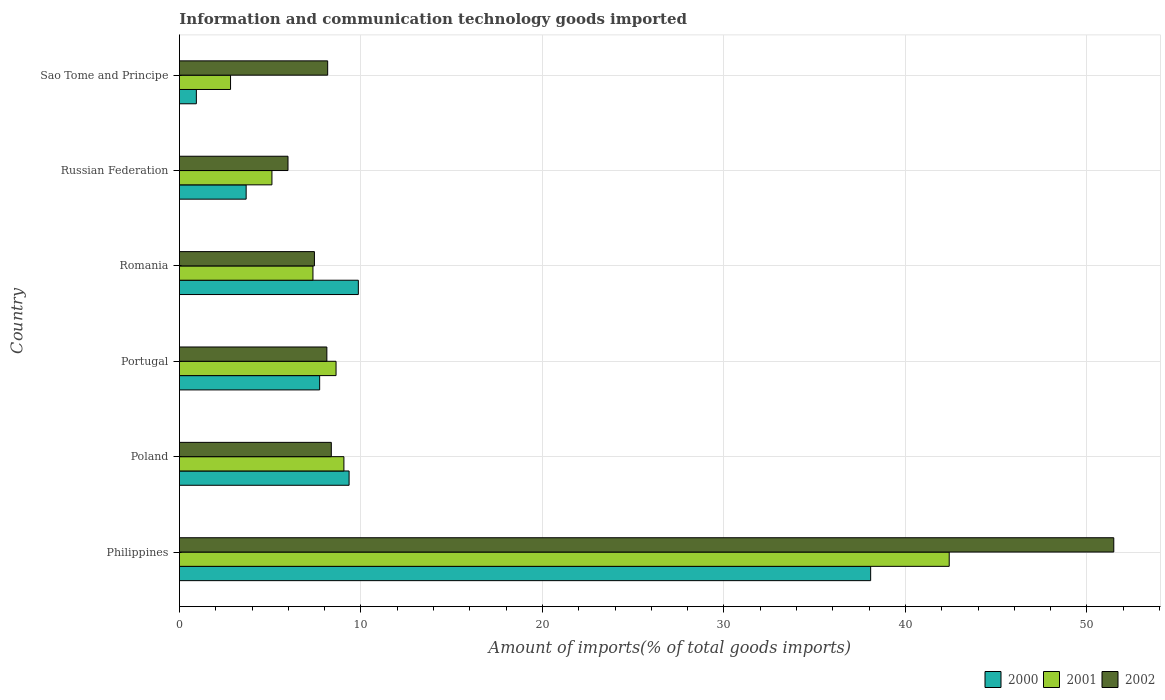How many groups of bars are there?
Your answer should be very brief. 6. Are the number of bars per tick equal to the number of legend labels?
Make the answer very short. Yes. What is the label of the 1st group of bars from the top?
Your answer should be compact. Sao Tome and Principe. In how many cases, is the number of bars for a given country not equal to the number of legend labels?
Ensure brevity in your answer.  0. What is the amount of goods imported in 2002 in Russian Federation?
Your answer should be very brief. 5.98. Across all countries, what is the maximum amount of goods imported in 2000?
Your response must be concise. 38.08. Across all countries, what is the minimum amount of goods imported in 2000?
Keep it short and to the point. 0.93. In which country was the amount of goods imported in 2001 minimum?
Keep it short and to the point. Sao Tome and Principe. What is the total amount of goods imported in 2000 in the graph?
Your answer should be very brief. 69.63. What is the difference between the amount of goods imported in 2000 in Portugal and that in Romania?
Keep it short and to the point. -2.13. What is the difference between the amount of goods imported in 2001 in Poland and the amount of goods imported in 2000 in Russian Federation?
Provide a short and direct response. 5.38. What is the average amount of goods imported in 2001 per country?
Make the answer very short. 12.56. What is the difference between the amount of goods imported in 2002 and amount of goods imported in 2000 in Poland?
Your answer should be very brief. -0.98. What is the ratio of the amount of goods imported in 2000 in Portugal to that in Sao Tome and Principe?
Offer a very short reply. 8.28. Is the amount of goods imported in 2000 in Philippines less than that in Portugal?
Offer a terse response. No. Is the difference between the amount of goods imported in 2002 in Philippines and Poland greater than the difference between the amount of goods imported in 2000 in Philippines and Poland?
Provide a short and direct response. Yes. What is the difference between the highest and the second highest amount of goods imported in 2000?
Your answer should be very brief. 28.22. What is the difference between the highest and the lowest amount of goods imported in 2000?
Provide a succinct answer. 37.15. Is the sum of the amount of goods imported in 2001 in Portugal and Sao Tome and Principe greater than the maximum amount of goods imported in 2000 across all countries?
Offer a terse response. No. What does the 3rd bar from the bottom in Russian Federation represents?
Offer a terse response. 2002. Is it the case that in every country, the sum of the amount of goods imported in 2000 and amount of goods imported in 2001 is greater than the amount of goods imported in 2002?
Your answer should be very brief. No. How many bars are there?
Offer a very short reply. 18. Are all the bars in the graph horizontal?
Give a very brief answer. Yes. How many countries are there in the graph?
Your answer should be compact. 6. Does the graph contain any zero values?
Your response must be concise. No. Does the graph contain grids?
Your answer should be very brief. Yes. Where does the legend appear in the graph?
Your answer should be very brief. Bottom right. What is the title of the graph?
Keep it short and to the point. Information and communication technology goods imported. Does "1979" appear as one of the legend labels in the graph?
Ensure brevity in your answer.  No. What is the label or title of the X-axis?
Provide a succinct answer. Amount of imports(% of total goods imports). What is the label or title of the Y-axis?
Provide a succinct answer. Country. What is the Amount of imports(% of total goods imports) of 2000 in Philippines?
Your response must be concise. 38.08. What is the Amount of imports(% of total goods imports) of 2001 in Philippines?
Offer a very short reply. 42.41. What is the Amount of imports(% of total goods imports) of 2002 in Philippines?
Offer a terse response. 51.48. What is the Amount of imports(% of total goods imports) of 2000 in Poland?
Make the answer very short. 9.35. What is the Amount of imports(% of total goods imports) in 2001 in Poland?
Your answer should be compact. 9.06. What is the Amount of imports(% of total goods imports) in 2002 in Poland?
Offer a terse response. 8.37. What is the Amount of imports(% of total goods imports) in 2000 in Portugal?
Offer a very short reply. 7.73. What is the Amount of imports(% of total goods imports) of 2001 in Portugal?
Your response must be concise. 8.63. What is the Amount of imports(% of total goods imports) in 2002 in Portugal?
Offer a terse response. 8.12. What is the Amount of imports(% of total goods imports) of 2000 in Romania?
Ensure brevity in your answer.  9.86. What is the Amount of imports(% of total goods imports) of 2001 in Romania?
Your answer should be compact. 7.36. What is the Amount of imports(% of total goods imports) in 2002 in Romania?
Provide a succinct answer. 7.44. What is the Amount of imports(% of total goods imports) of 2000 in Russian Federation?
Provide a succinct answer. 3.68. What is the Amount of imports(% of total goods imports) of 2001 in Russian Federation?
Give a very brief answer. 5.1. What is the Amount of imports(% of total goods imports) in 2002 in Russian Federation?
Ensure brevity in your answer.  5.98. What is the Amount of imports(% of total goods imports) in 2000 in Sao Tome and Principe?
Keep it short and to the point. 0.93. What is the Amount of imports(% of total goods imports) in 2001 in Sao Tome and Principe?
Offer a terse response. 2.82. What is the Amount of imports(% of total goods imports) in 2002 in Sao Tome and Principe?
Ensure brevity in your answer.  8.17. Across all countries, what is the maximum Amount of imports(% of total goods imports) in 2000?
Your response must be concise. 38.08. Across all countries, what is the maximum Amount of imports(% of total goods imports) of 2001?
Your answer should be very brief. 42.41. Across all countries, what is the maximum Amount of imports(% of total goods imports) of 2002?
Offer a very short reply. 51.48. Across all countries, what is the minimum Amount of imports(% of total goods imports) of 2000?
Offer a terse response. 0.93. Across all countries, what is the minimum Amount of imports(% of total goods imports) of 2001?
Make the answer very short. 2.82. Across all countries, what is the minimum Amount of imports(% of total goods imports) in 2002?
Provide a short and direct response. 5.98. What is the total Amount of imports(% of total goods imports) in 2000 in the graph?
Provide a short and direct response. 69.63. What is the total Amount of imports(% of total goods imports) in 2001 in the graph?
Provide a short and direct response. 75.37. What is the total Amount of imports(% of total goods imports) in 2002 in the graph?
Keep it short and to the point. 89.56. What is the difference between the Amount of imports(% of total goods imports) of 2000 in Philippines and that in Poland?
Offer a terse response. 28.73. What is the difference between the Amount of imports(% of total goods imports) of 2001 in Philippines and that in Poland?
Your response must be concise. 33.35. What is the difference between the Amount of imports(% of total goods imports) in 2002 in Philippines and that in Poland?
Make the answer very short. 43.11. What is the difference between the Amount of imports(% of total goods imports) of 2000 in Philippines and that in Portugal?
Your answer should be compact. 30.36. What is the difference between the Amount of imports(% of total goods imports) of 2001 in Philippines and that in Portugal?
Provide a succinct answer. 33.78. What is the difference between the Amount of imports(% of total goods imports) in 2002 in Philippines and that in Portugal?
Your answer should be compact. 43.35. What is the difference between the Amount of imports(% of total goods imports) in 2000 in Philippines and that in Romania?
Ensure brevity in your answer.  28.22. What is the difference between the Amount of imports(% of total goods imports) in 2001 in Philippines and that in Romania?
Give a very brief answer. 35.05. What is the difference between the Amount of imports(% of total goods imports) in 2002 in Philippines and that in Romania?
Your answer should be compact. 44.04. What is the difference between the Amount of imports(% of total goods imports) of 2000 in Philippines and that in Russian Federation?
Ensure brevity in your answer.  34.41. What is the difference between the Amount of imports(% of total goods imports) in 2001 in Philippines and that in Russian Federation?
Keep it short and to the point. 37.31. What is the difference between the Amount of imports(% of total goods imports) in 2002 in Philippines and that in Russian Federation?
Provide a short and direct response. 45.49. What is the difference between the Amount of imports(% of total goods imports) in 2000 in Philippines and that in Sao Tome and Principe?
Provide a short and direct response. 37.15. What is the difference between the Amount of imports(% of total goods imports) in 2001 in Philippines and that in Sao Tome and Principe?
Your response must be concise. 39.59. What is the difference between the Amount of imports(% of total goods imports) in 2002 in Philippines and that in Sao Tome and Principe?
Provide a succinct answer. 43.31. What is the difference between the Amount of imports(% of total goods imports) of 2000 in Poland and that in Portugal?
Your response must be concise. 1.62. What is the difference between the Amount of imports(% of total goods imports) of 2001 in Poland and that in Portugal?
Provide a short and direct response. 0.43. What is the difference between the Amount of imports(% of total goods imports) of 2002 in Poland and that in Portugal?
Your response must be concise. 0.25. What is the difference between the Amount of imports(% of total goods imports) in 2000 in Poland and that in Romania?
Your response must be concise. -0.51. What is the difference between the Amount of imports(% of total goods imports) of 2001 in Poland and that in Romania?
Provide a succinct answer. 1.71. What is the difference between the Amount of imports(% of total goods imports) of 2002 in Poland and that in Romania?
Your response must be concise. 0.93. What is the difference between the Amount of imports(% of total goods imports) of 2000 in Poland and that in Russian Federation?
Your response must be concise. 5.67. What is the difference between the Amount of imports(% of total goods imports) in 2001 in Poland and that in Russian Federation?
Your answer should be compact. 3.97. What is the difference between the Amount of imports(% of total goods imports) of 2002 in Poland and that in Russian Federation?
Give a very brief answer. 2.39. What is the difference between the Amount of imports(% of total goods imports) of 2000 in Poland and that in Sao Tome and Principe?
Make the answer very short. 8.41. What is the difference between the Amount of imports(% of total goods imports) of 2001 in Poland and that in Sao Tome and Principe?
Make the answer very short. 6.25. What is the difference between the Amount of imports(% of total goods imports) in 2002 in Poland and that in Sao Tome and Principe?
Give a very brief answer. 0.2. What is the difference between the Amount of imports(% of total goods imports) of 2000 in Portugal and that in Romania?
Keep it short and to the point. -2.13. What is the difference between the Amount of imports(% of total goods imports) in 2001 in Portugal and that in Romania?
Provide a short and direct response. 1.27. What is the difference between the Amount of imports(% of total goods imports) in 2002 in Portugal and that in Romania?
Offer a very short reply. 0.69. What is the difference between the Amount of imports(% of total goods imports) of 2000 in Portugal and that in Russian Federation?
Offer a terse response. 4.05. What is the difference between the Amount of imports(% of total goods imports) in 2001 in Portugal and that in Russian Federation?
Your response must be concise. 3.53. What is the difference between the Amount of imports(% of total goods imports) of 2002 in Portugal and that in Russian Federation?
Offer a terse response. 2.14. What is the difference between the Amount of imports(% of total goods imports) of 2000 in Portugal and that in Sao Tome and Principe?
Make the answer very short. 6.79. What is the difference between the Amount of imports(% of total goods imports) of 2001 in Portugal and that in Sao Tome and Principe?
Ensure brevity in your answer.  5.81. What is the difference between the Amount of imports(% of total goods imports) in 2002 in Portugal and that in Sao Tome and Principe?
Your answer should be very brief. -0.04. What is the difference between the Amount of imports(% of total goods imports) of 2000 in Romania and that in Russian Federation?
Offer a very short reply. 6.18. What is the difference between the Amount of imports(% of total goods imports) in 2001 in Romania and that in Russian Federation?
Ensure brevity in your answer.  2.26. What is the difference between the Amount of imports(% of total goods imports) of 2002 in Romania and that in Russian Federation?
Provide a short and direct response. 1.46. What is the difference between the Amount of imports(% of total goods imports) in 2000 in Romania and that in Sao Tome and Principe?
Your response must be concise. 8.92. What is the difference between the Amount of imports(% of total goods imports) of 2001 in Romania and that in Sao Tome and Principe?
Your response must be concise. 4.54. What is the difference between the Amount of imports(% of total goods imports) of 2002 in Romania and that in Sao Tome and Principe?
Provide a short and direct response. -0.73. What is the difference between the Amount of imports(% of total goods imports) in 2000 in Russian Federation and that in Sao Tome and Principe?
Provide a short and direct response. 2.74. What is the difference between the Amount of imports(% of total goods imports) in 2001 in Russian Federation and that in Sao Tome and Principe?
Your response must be concise. 2.28. What is the difference between the Amount of imports(% of total goods imports) in 2002 in Russian Federation and that in Sao Tome and Principe?
Provide a succinct answer. -2.19. What is the difference between the Amount of imports(% of total goods imports) of 2000 in Philippines and the Amount of imports(% of total goods imports) of 2001 in Poland?
Make the answer very short. 29.02. What is the difference between the Amount of imports(% of total goods imports) of 2000 in Philippines and the Amount of imports(% of total goods imports) of 2002 in Poland?
Your answer should be very brief. 29.71. What is the difference between the Amount of imports(% of total goods imports) in 2001 in Philippines and the Amount of imports(% of total goods imports) in 2002 in Poland?
Keep it short and to the point. 34.04. What is the difference between the Amount of imports(% of total goods imports) of 2000 in Philippines and the Amount of imports(% of total goods imports) of 2001 in Portugal?
Offer a terse response. 29.45. What is the difference between the Amount of imports(% of total goods imports) in 2000 in Philippines and the Amount of imports(% of total goods imports) in 2002 in Portugal?
Give a very brief answer. 29.96. What is the difference between the Amount of imports(% of total goods imports) in 2001 in Philippines and the Amount of imports(% of total goods imports) in 2002 in Portugal?
Your answer should be very brief. 34.29. What is the difference between the Amount of imports(% of total goods imports) of 2000 in Philippines and the Amount of imports(% of total goods imports) of 2001 in Romania?
Make the answer very short. 30.73. What is the difference between the Amount of imports(% of total goods imports) of 2000 in Philippines and the Amount of imports(% of total goods imports) of 2002 in Romania?
Give a very brief answer. 30.64. What is the difference between the Amount of imports(% of total goods imports) in 2001 in Philippines and the Amount of imports(% of total goods imports) in 2002 in Romania?
Give a very brief answer. 34.97. What is the difference between the Amount of imports(% of total goods imports) in 2000 in Philippines and the Amount of imports(% of total goods imports) in 2001 in Russian Federation?
Offer a terse response. 32.99. What is the difference between the Amount of imports(% of total goods imports) of 2000 in Philippines and the Amount of imports(% of total goods imports) of 2002 in Russian Federation?
Offer a terse response. 32.1. What is the difference between the Amount of imports(% of total goods imports) in 2001 in Philippines and the Amount of imports(% of total goods imports) in 2002 in Russian Federation?
Make the answer very short. 36.43. What is the difference between the Amount of imports(% of total goods imports) in 2000 in Philippines and the Amount of imports(% of total goods imports) in 2001 in Sao Tome and Principe?
Give a very brief answer. 35.27. What is the difference between the Amount of imports(% of total goods imports) in 2000 in Philippines and the Amount of imports(% of total goods imports) in 2002 in Sao Tome and Principe?
Offer a terse response. 29.91. What is the difference between the Amount of imports(% of total goods imports) in 2001 in Philippines and the Amount of imports(% of total goods imports) in 2002 in Sao Tome and Principe?
Make the answer very short. 34.24. What is the difference between the Amount of imports(% of total goods imports) of 2000 in Poland and the Amount of imports(% of total goods imports) of 2001 in Portugal?
Offer a very short reply. 0.72. What is the difference between the Amount of imports(% of total goods imports) of 2000 in Poland and the Amount of imports(% of total goods imports) of 2002 in Portugal?
Give a very brief answer. 1.23. What is the difference between the Amount of imports(% of total goods imports) of 2001 in Poland and the Amount of imports(% of total goods imports) of 2002 in Portugal?
Offer a very short reply. 0.94. What is the difference between the Amount of imports(% of total goods imports) of 2000 in Poland and the Amount of imports(% of total goods imports) of 2001 in Romania?
Your answer should be very brief. 1.99. What is the difference between the Amount of imports(% of total goods imports) of 2000 in Poland and the Amount of imports(% of total goods imports) of 2002 in Romania?
Your response must be concise. 1.91. What is the difference between the Amount of imports(% of total goods imports) of 2001 in Poland and the Amount of imports(% of total goods imports) of 2002 in Romania?
Your response must be concise. 1.62. What is the difference between the Amount of imports(% of total goods imports) in 2000 in Poland and the Amount of imports(% of total goods imports) in 2001 in Russian Federation?
Keep it short and to the point. 4.25. What is the difference between the Amount of imports(% of total goods imports) in 2000 in Poland and the Amount of imports(% of total goods imports) in 2002 in Russian Federation?
Offer a terse response. 3.37. What is the difference between the Amount of imports(% of total goods imports) in 2001 in Poland and the Amount of imports(% of total goods imports) in 2002 in Russian Federation?
Your answer should be very brief. 3.08. What is the difference between the Amount of imports(% of total goods imports) of 2000 in Poland and the Amount of imports(% of total goods imports) of 2001 in Sao Tome and Principe?
Ensure brevity in your answer.  6.53. What is the difference between the Amount of imports(% of total goods imports) in 2000 in Poland and the Amount of imports(% of total goods imports) in 2002 in Sao Tome and Principe?
Your answer should be compact. 1.18. What is the difference between the Amount of imports(% of total goods imports) of 2001 in Poland and the Amount of imports(% of total goods imports) of 2002 in Sao Tome and Principe?
Offer a terse response. 0.89. What is the difference between the Amount of imports(% of total goods imports) in 2000 in Portugal and the Amount of imports(% of total goods imports) in 2001 in Romania?
Ensure brevity in your answer.  0.37. What is the difference between the Amount of imports(% of total goods imports) of 2000 in Portugal and the Amount of imports(% of total goods imports) of 2002 in Romania?
Make the answer very short. 0.29. What is the difference between the Amount of imports(% of total goods imports) in 2001 in Portugal and the Amount of imports(% of total goods imports) in 2002 in Romania?
Offer a very short reply. 1.19. What is the difference between the Amount of imports(% of total goods imports) of 2000 in Portugal and the Amount of imports(% of total goods imports) of 2001 in Russian Federation?
Provide a short and direct response. 2.63. What is the difference between the Amount of imports(% of total goods imports) in 2000 in Portugal and the Amount of imports(% of total goods imports) in 2002 in Russian Federation?
Your answer should be very brief. 1.74. What is the difference between the Amount of imports(% of total goods imports) in 2001 in Portugal and the Amount of imports(% of total goods imports) in 2002 in Russian Federation?
Your response must be concise. 2.65. What is the difference between the Amount of imports(% of total goods imports) in 2000 in Portugal and the Amount of imports(% of total goods imports) in 2001 in Sao Tome and Principe?
Provide a succinct answer. 4.91. What is the difference between the Amount of imports(% of total goods imports) in 2000 in Portugal and the Amount of imports(% of total goods imports) in 2002 in Sao Tome and Principe?
Provide a short and direct response. -0.44. What is the difference between the Amount of imports(% of total goods imports) of 2001 in Portugal and the Amount of imports(% of total goods imports) of 2002 in Sao Tome and Principe?
Offer a very short reply. 0.46. What is the difference between the Amount of imports(% of total goods imports) in 2000 in Romania and the Amount of imports(% of total goods imports) in 2001 in Russian Federation?
Give a very brief answer. 4.76. What is the difference between the Amount of imports(% of total goods imports) in 2000 in Romania and the Amount of imports(% of total goods imports) in 2002 in Russian Federation?
Your answer should be compact. 3.88. What is the difference between the Amount of imports(% of total goods imports) in 2001 in Romania and the Amount of imports(% of total goods imports) in 2002 in Russian Federation?
Provide a succinct answer. 1.37. What is the difference between the Amount of imports(% of total goods imports) of 2000 in Romania and the Amount of imports(% of total goods imports) of 2001 in Sao Tome and Principe?
Keep it short and to the point. 7.04. What is the difference between the Amount of imports(% of total goods imports) in 2000 in Romania and the Amount of imports(% of total goods imports) in 2002 in Sao Tome and Principe?
Give a very brief answer. 1.69. What is the difference between the Amount of imports(% of total goods imports) of 2001 in Romania and the Amount of imports(% of total goods imports) of 2002 in Sao Tome and Principe?
Keep it short and to the point. -0.81. What is the difference between the Amount of imports(% of total goods imports) of 2000 in Russian Federation and the Amount of imports(% of total goods imports) of 2001 in Sao Tome and Principe?
Make the answer very short. 0.86. What is the difference between the Amount of imports(% of total goods imports) in 2000 in Russian Federation and the Amount of imports(% of total goods imports) in 2002 in Sao Tome and Principe?
Keep it short and to the point. -4.49. What is the difference between the Amount of imports(% of total goods imports) of 2001 in Russian Federation and the Amount of imports(% of total goods imports) of 2002 in Sao Tome and Principe?
Ensure brevity in your answer.  -3.07. What is the average Amount of imports(% of total goods imports) in 2000 per country?
Your response must be concise. 11.6. What is the average Amount of imports(% of total goods imports) of 2001 per country?
Offer a very short reply. 12.56. What is the average Amount of imports(% of total goods imports) of 2002 per country?
Provide a short and direct response. 14.93. What is the difference between the Amount of imports(% of total goods imports) of 2000 and Amount of imports(% of total goods imports) of 2001 in Philippines?
Make the answer very short. -4.33. What is the difference between the Amount of imports(% of total goods imports) of 2000 and Amount of imports(% of total goods imports) of 2002 in Philippines?
Your response must be concise. -13.39. What is the difference between the Amount of imports(% of total goods imports) of 2001 and Amount of imports(% of total goods imports) of 2002 in Philippines?
Your answer should be very brief. -9.07. What is the difference between the Amount of imports(% of total goods imports) of 2000 and Amount of imports(% of total goods imports) of 2001 in Poland?
Make the answer very short. 0.29. What is the difference between the Amount of imports(% of total goods imports) of 2000 and Amount of imports(% of total goods imports) of 2002 in Poland?
Give a very brief answer. 0.98. What is the difference between the Amount of imports(% of total goods imports) in 2001 and Amount of imports(% of total goods imports) in 2002 in Poland?
Provide a short and direct response. 0.69. What is the difference between the Amount of imports(% of total goods imports) in 2000 and Amount of imports(% of total goods imports) in 2001 in Portugal?
Give a very brief answer. -0.9. What is the difference between the Amount of imports(% of total goods imports) in 2000 and Amount of imports(% of total goods imports) in 2002 in Portugal?
Make the answer very short. -0.4. What is the difference between the Amount of imports(% of total goods imports) in 2001 and Amount of imports(% of total goods imports) in 2002 in Portugal?
Provide a succinct answer. 0.51. What is the difference between the Amount of imports(% of total goods imports) in 2000 and Amount of imports(% of total goods imports) in 2001 in Romania?
Offer a terse response. 2.5. What is the difference between the Amount of imports(% of total goods imports) of 2000 and Amount of imports(% of total goods imports) of 2002 in Romania?
Make the answer very short. 2.42. What is the difference between the Amount of imports(% of total goods imports) in 2001 and Amount of imports(% of total goods imports) in 2002 in Romania?
Offer a terse response. -0.08. What is the difference between the Amount of imports(% of total goods imports) in 2000 and Amount of imports(% of total goods imports) in 2001 in Russian Federation?
Provide a succinct answer. -1.42. What is the difference between the Amount of imports(% of total goods imports) in 2000 and Amount of imports(% of total goods imports) in 2002 in Russian Federation?
Your response must be concise. -2.3. What is the difference between the Amount of imports(% of total goods imports) of 2001 and Amount of imports(% of total goods imports) of 2002 in Russian Federation?
Ensure brevity in your answer.  -0.89. What is the difference between the Amount of imports(% of total goods imports) in 2000 and Amount of imports(% of total goods imports) in 2001 in Sao Tome and Principe?
Your answer should be very brief. -1.88. What is the difference between the Amount of imports(% of total goods imports) of 2000 and Amount of imports(% of total goods imports) of 2002 in Sao Tome and Principe?
Your answer should be compact. -7.23. What is the difference between the Amount of imports(% of total goods imports) of 2001 and Amount of imports(% of total goods imports) of 2002 in Sao Tome and Principe?
Keep it short and to the point. -5.35. What is the ratio of the Amount of imports(% of total goods imports) of 2000 in Philippines to that in Poland?
Ensure brevity in your answer.  4.07. What is the ratio of the Amount of imports(% of total goods imports) of 2001 in Philippines to that in Poland?
Ensure brevity in your answer.  4.68. What is the ratio of the Amount of imports(% of total goods imports) in 2002 in Philippines to that in Poland?
Give a very brief answer. 6.15. What is the ratio of the Amount of imports(% of total goods imports) in 2000 in Philippines to that in Portugal?
Make the answer very short. 4.93. What is the ratio of the Amount of imports(% of total goods imports) in 2001 in Philippines to that in Portugal?
Your answer should be compact. 4.91. What is the ratio of the Amount of imports(% of total goods imports) of 2002 in Philippines to that in Portugal?
Make the answer very short. 6.34. What is the ratio of the Amount of imports(% of total goods imports) of 2000 in Philippines to that in Romania?
Your answer should be very brief. 3.86. What is the ratio of the Amount of imports(% of total goods imports) in 2001 in Philippines to that in Romania?
Make the answer very short. 5.76. What is the ratio of the Amount of imports(% of total goods imports) of 2002 in Philippines to that in Romania?
Offer a very short reply. 6.92. What is the ratio of the Amount of imports(% of total goods imports) in 2000 in Philippines to that in Russian Federation?
Make the answer very short. 10.36. What is the ratio of the Amount of imports(% of total goods imports) of 2001 in Philippines to that in Russian Federation?
Keep it short and to the point. 8.32. What is the ratio of the Amount of imports(% of total goods imports) of 2002 in Philippines to that in Russian Federation?
Make the answer very short. 8.61. What is the ratio of the Amount of imports(% of total goods imports) in 2000 in Philippines to that in Sao Tome and Principe?
Make the answer very short. 40.8. What is the ratio of the Amount of imports(% of total goods imports) in 2001 in Philippines to that in Sao Tome and Principe?
Give a very brief answer. 15.06. What is the ratio of the Amount of imports(% of total goods imports) in 2002 in Philippines to that in Sao Tome and Principe?
Provide a succinct answer. 6.3. What is the ratio of the Amount of imports(% of total goods imports) of 2000 in Poland to that in Portugal?
Make the answer very short. 1.21. What is the ratio of the Amount of imports(% of total goods imports) of 2001 in Poland to that in Portugal?
Your response must be concise. 1.05. What is the ratio of the Amount of imports(% of total goods imports) in 2002 in Poland to that in Portugal?
Give a very brief answer. 1.03. What is the ratio of the Amount of imports(% of total goods imports) of 2000 in Poland to that in Romania?
Offer a very short reply. 0.95. What is the ratio of the Amount of imports(% of total goods imports) in 2001 in Poland to that in Romania?
Provide a succinct answer. 1.23. What is the ratio of the Amount of imports(% of total goods imports) of 2002 in Poland to that in Romania?
Provide a succinct answer. 1.13. What is the ratio of the Amount of imports(% of total goods imports) in 2000 in Poland to that in Russian Federation?
Provide a short and direct response. 2.54. What is the ratio of the Amount of imports(% of total goods imports) of 2001 in Poland to that in Russian Federation?
Ensure brevity in your answer.  1.78. What is the ratio of the Amount of imports(% of total goods imports) in 2002 in Poland to that in Russian Federation?
Give a very brief answer. 1.4. What is the ratio of the Amount of imports(% of total goods imports) of 2000 in Poland to that in Sao Tome and Principe?
Make the answer very short. 10.01. What is the ratio of the Amount of imports(% of total goods imports) of 2001 in Poland to that in Sao Tome and Principe?
Your response must be concise. 3.22. What is the ratio of the Amount of imports(% of total goods imports) of 2002 in Poland to that in Sao Tome and Principe?
Ensure brevity in your answer.  1.02. What is the ratio of the Amount of imports(% of total goods imports) in 2000 in Portugal to that in Romania?
Offer a very short reply. 0.78. What is the ratio of the Amount of imports(% of total goods imports) in 2001 in Portugal to that in Romania?
Offer a terse response. 1.17. What is the ratio of the Amount of imports(% of total goods imports) in 2002 in Portugal to that in Romania?
Your answer should be very brief. 1.09. What is the ratio of the Amount of imports(% of total goods imports) of 2000 in Portugal to that in Russian Federation?
Keep it short and to the point. 2.1. What is the ratio of the Amount of imports(% of total goods imports) of 2001 in Portugal to that in Russian Federation?
Keep it short and to the point. 1.69. What is the ratio of the Amount of imports(% of total goods imports) of 2002 in Portugal to that in Russian Federation?
Keep it short and to the point. 1.36. What is the ratio of the Amount of imports(% of total goods imports) of 2000 in Portugal to that in Sao Tome and Principe?
Offer a very short reply. 8.28. What is the ratio of the Amount of imports(% of total goods imports) of 2001 in Portugal to that in Sao Tome and Principe?
Give a very brief answer. 3.06. What is the ratio of the Amount of imports(% of total goods imports) of 2000 in Romania to that in Russian Federation?
Provide a short and direct response. 2.68. What is the ratio of the Amount of imports(% of total goods imports) of 2001 in Romania to that in Russian Federation?
Make the answer very short. 1.44. What is the ratio of the Amount of imports(% of total goods imports) of 2002 in Romania to that in Russian Federation?
Make the answer very short. 1.24. What is the ratio of the Amount of imports(% of total goods imports) in 2000 in Romania to that in Sao Tome and Principe?
Offer a very short reply. 10.56. What is the ratio of the Amount of imports(% of total goods imports) of 2001 in Romania to that in Sao Tome and Principe?
Make the answer very short. 2.61. What is the ratio of the Amount of imports(% of total goods imports) of 2002 in Romania to that in Sao Tome and Principe?
Provide a short and direct response. 0.91. What is the ratio of the Amount of imports(% of total goods imports) of 2000 in Russian Federation to that in Sao Tome and Principe?
Make the answer very short. 3.94. What is the ratio of the Amount of imports(% of total goods imports) of 2001 in Russian Federation to that in Sao Tome and Principe?
Your answer should be compact. 1.81. What is the ratio of the Amount of imports(% of total goods imports) in 2002 in Russian Federation to that in Sao Tome and Principe?
Ensure brevity in your answer.  0.73. What is the difference between the highest and the second highest Amount of imports(% of total goods imports) of 2000?
Provide a short and direct response. 28.22. What is the difference between the highest and the second highest Amount of imports(% of total goods imports) in 2001?
Provide a short and direct response. 33.35. What is the difference between the highest and the second highest Amount of imports(% of total goods imports) in 2002?
Your answer should be very brief. 43.11. What is the difference between the highest and the lowest Amount of imports(% of total goods imports) of 2000?
Your answer should be very brief. 37.15. What is the difference between the highest and the lowest Amount of imports(% of total goods imports) in 2001?
Make the answer very short. 39.59. What is the difference between the highest and the lowest Amount of imports(% of total goods imports) of 2002?
Your response must be concise. 45.49. 